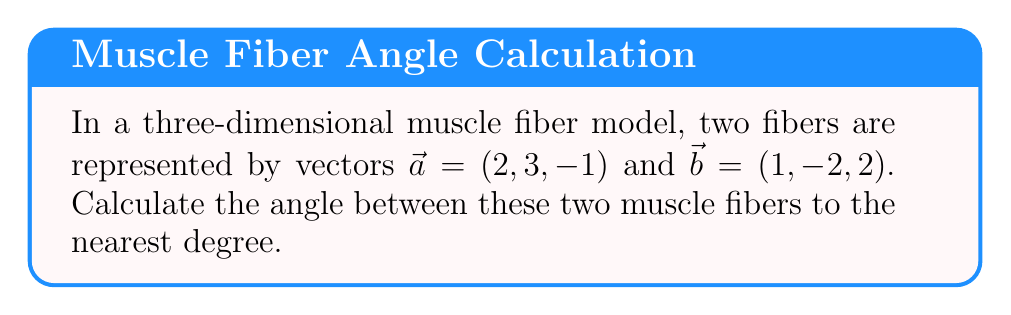Teach me how to tackle this problem. To find the angle between two vectors in three-dimensional space, we can use the dot product formula:

$$\cos \theta = \frac{\vec{a} \cdot \vec{b}}{|\vec{a}||\vec{b}|}$$

Where $\theta$ is the angle between the vectors, $\vec{a} \cdot \vec{b}$ is the dot product, and $|\vec{a}|$ and $|\vec{b}|$ are the magnitudes of the vectors.

Step 1: Calculate the dot product $\vec{a} \cdot \vec{b}$
$$\vec{a} \cdot \vec{b} = (2)(1) + (3)(-2) + (-1)(2) = 2 - 6 - 2 = -6$$

Step 2: Calculate the magnitudes of $\vec{a}$ and $\vec{b}$
$$|\vec{a}| = \sqrt{2^2 + 3^2 + (-1)^2} = \sqrt{4 + 9 + 1} = \sqrt{14}$$
$$|\vec{b}| = \sqrt{1^2 + (-2)^2 + 2^2} = \sqrt{1 + 4 + 4} = 3$$

Step 3: Substitute the values into the formula
$$\cos \theta = \frac{-6}{\sqrt{14} \cdot 3} = \frac{-6}{3\sqrt{14}}$$

Step 4: Take the inverse cosine (arccos) of both sides
$$\theta = \arccos\left(\frac{-6}{3\sqrt{14}}\right)$$

Step 5: Calculate the result and round to the nearest degree
$$\theta \approx 126.87^\circ \approx 127^\circ$$
Answer: $127^\circ$ 